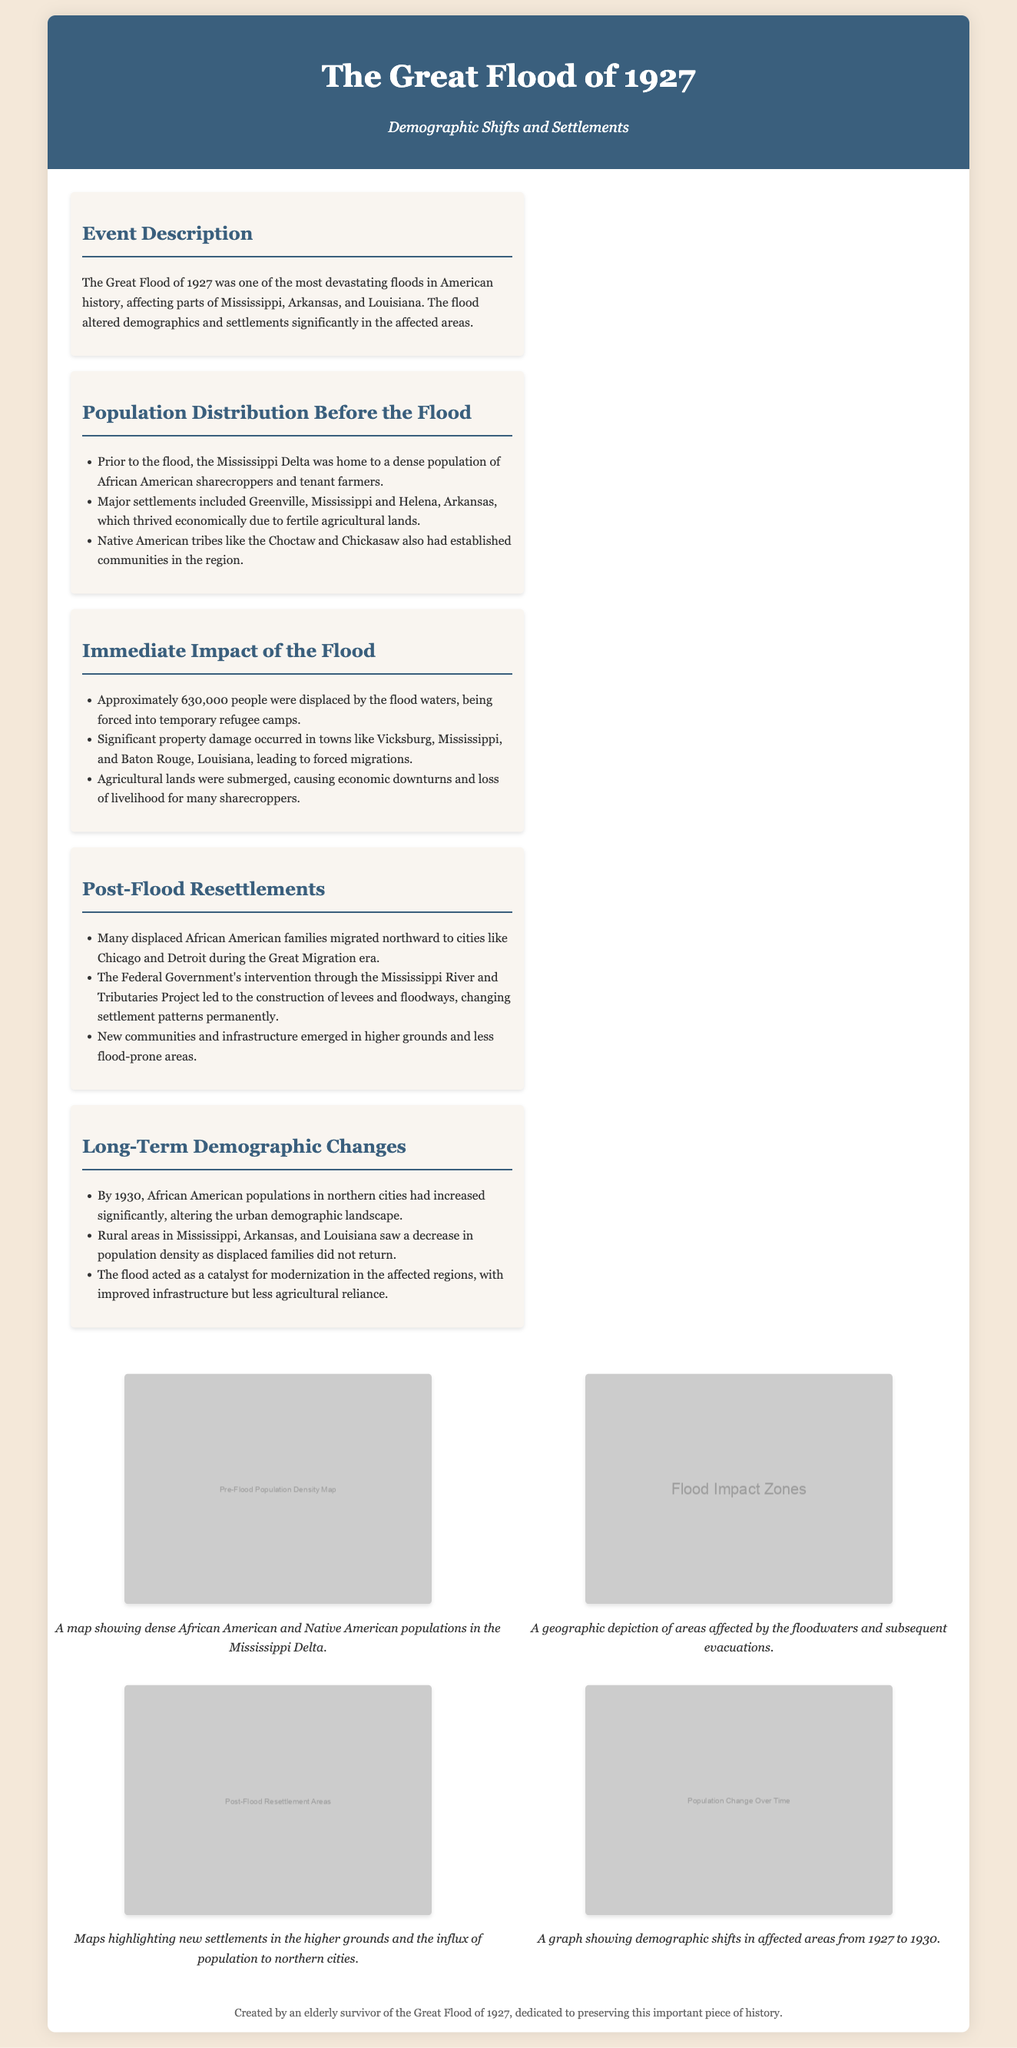What significant event occurred in 1927? The document mentions that the Great Flood of 1927 was one of the most devastating floods in American history.
Answer: Great Flood of 1927 How many people were displaced by the flood? The document states that approximately 630,000 people were displaced by the flood waters.
Answer: 630,000 Which two cities did many displaced families migrate to? The document lists that many displaced African American families migrated northward to cities like Chicago and Detroit.
Answer: Chicago and Detroit What was the impact of the flood on agricultural lands? The document mentions that agricultural lands were submerged, causing economic downturns and loss of livelihood for many sharecroppers.
Answer: Submerged What demographic change occurred by 1930 in northern cities? The document indicates that by 1930, African American populations in northern cities had increased significantly, altering the urban demographic landscape.
Answer: Increased African American populations What type of project did the Federal Government intervene with? The document specifies that the Federal Government's intervention was through the Mississippi River and Tributaries Project.
Answer: Mississippi River and Tributaries Project Name one type of map included in the document. The document includes multiple maps, one of which is the Pre-Flood Population Density Map.
Answer: Pre-Flood Population Density Map What did the flood act as a catalyst for in affected regions? The document states that the flood acted as a catalyst for modernization in the affected regions.
Answer: Modernization 